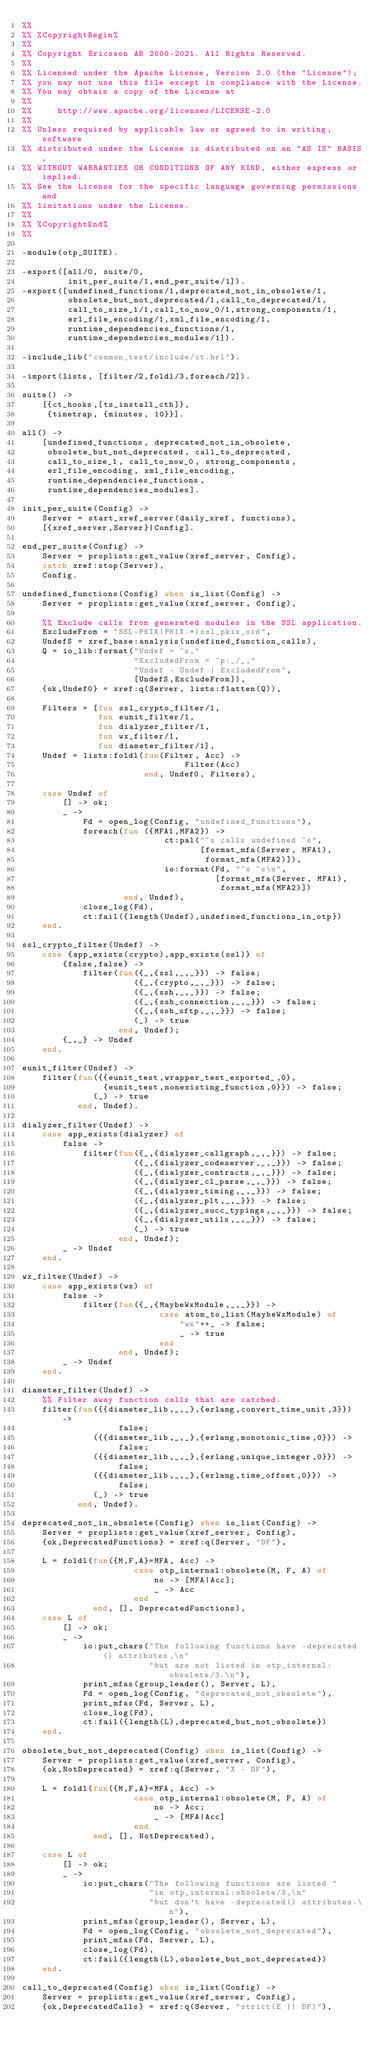Convert code to text. <code><loc_0><loc_0><loc_500><loc_500><_Erlang_>%%
%% %CopyrightBegin%
%%
%% Copyright Ericsson AB 2000-2021. All Rights Reserved.
%%
%% Licensed under the Apache License, Version 2.0 (the "License");
%% you may not use this file except in compliance with the License.
%% You may obtain a copy of the License at
%%
%%     http://www.apache.org/licenses/LICENSE-2.0
%%
%% Unless required by applicable law or agreed to in writing, software
%% distributed under the License is distributed on an "AS IS" BASIS,
%% WITHOUT WARRANTIES OR CONDITIONS OF ANY KIND, either express or implied.
%% See the License for the specific language governing permissions and
%% limitations under the License.
%%
%% %CopyrightEnd%
%%

-module(otp_SUITE).

-export([all/0, suite/0,
         init_per_suite/1,end_per_suite/1]).
-export([undefined_functions/1,deprecated_not_in_obsolete/1,
         obsolete_but_not_deprecated/1,call_to_deprecated/1,
         call_to_size_1/1,call_to_now_0/1,strong_components/1,
         erl_file_encoding/1,xml_file_encoding/1,
         runtime_dependencies_functions/1,
         runtime_dependencies_modules/1]).

-include_lib("common_test/include/ct.hrl").

-import(lists, [filter/2,foldl/3,foreach/2]).

suite() ->
    [{ct_hooks,[ts_install_cth]},
     {timetrap, {minutes, 10}}].

all() -> 
    [undefined_functions, deprecated_not_in_obsolete,
     obsolete_but_not_deprecated, call_to_deprecated,
     call_to_size_1, call_to_now_0, strong_components,
     erl_file_encoding, xml_file_encoding,
     runtime_dependencies_functions,
     runtime_dependencies_modules].

init_per_suite(Config) ->
    Server = start_xref_server(daily_xref, functions),
    [{xref_server,Server}|Config].

end_per_suite(Config) ->
    Server = proplists:get_value(xref_server, Config),
    catch xref:stop(Server),
    Config.

undefined_functions(Config) when is_list(Config) ->
    Server = proplists:get_value(xref_server, Config),

    %% Exclude calls from generated modules in the SSL application.
    ExcludeFrom = "SSL-PKIX|PKIX.*|ssl_pkix_oid",
    UndefS = xref_base:analysis(undefined_function_calls),
    Q = io_lib:format("Undef = ~s,"
                      "ExcludedFrom = ~p:_/_,"
                      "Undef - Undef | ExcludedFrom",
                      [UndefS,ExcludeFrom]),
    {ok,Undef0} = xref:q(Server, lists:flatten(Q)),

    Filters = [fun ssl_crypto_filter/1,
               fun eunit_filter/1,
               fun dialyzer_filter/1,
               fun wx_filter/1,
               fun diameter_filter/1],
    Undef = lists:foldl(fun(Filter, Acc) ->
                                Filter(Acc)
                        end, Undef0, Filters),

    case Undef of
        [] -> ok;
        _ ->
            Fd = open_log(Config, "undefined_functions"),
            foreach(fun ({MFA1,MFA2}) ->
                            ct:pal("~s calls undefined ~s",
                                   [format_mfa(Server, MFA1),
                                    format_mfa(MFA2)]),
                            io:format(Fd, "~s ~s\n",
                                      [format_mfa(Server, MFA1),
                                       format_mfa(MFA2)])
                    end, Undef),
            close_log(Fd),
            ct:fail({length(Undef),undefined_functions_in_otp})
    end.

ssl_crypto_filter(Undef) ->
    case {app_exists(crypto),app_exists(ssl)} of
        {false,false} ->
            filter(fun({_,{ssl,_,_}}) -> false;
                      ({_,{crypto,_,_}}) -> false;
                      ({_,{ssh,_,_}}) -> false;
                      ({_,{ssh_connection,_,_}}) -> false;
                      ({_,{ssh_sftp,_,_}}) -> false;
                      (_) -> true
                   end, Undef);
        {_,_} -> Undef
    end.

eunit_filter(Undef) ->
    filter(fun({{eunit_test,wrapper_test_exported_,0},
                {eunit_test,nonexisting_function,0}}) -> false;
              (_) -> true
           end, Undef).

dialyzer_filter(Undef) ->
    case app_exists(dialyzer) of
        false ->
            filter(fun({_,{dialyzer_callgraph,_,_}}) -> false;
                      ({_,{dialyzer_codeserver,_,_}}) -> false;
                      ({_,{dialyzer_contracts,_,_}}) -> false;
                      ({_,{dialyzer_cl_parse,_,_}}) -> false;
                      ({_,{dialyzer_timing,_,_}}) -> false;
                      ({_,{dialyzer_plt,_,_}}) -> false;
                      ({_,{dialyzer_succ_typings,_,_}}) -> false;
                      ({_,{dialyzer_utils,_,_}}) -> false;
                      (_) -> true
                   end, Undef);
        _ -> Undef
    end.

wx_filter(Undef) ->
    case app_exists(wx) of
        false ->
            filter(fun({_,{MaybeWxModule,_,_}}) ->
                           case atom_to_list(MaybeWxModule) of
                               "wx"++_ -> false;
                               _ -> true
                           end
                   end, Undef);
        _ -> Undef
    end.

diameter_filter(Undef) ->
    %% Filter away function calls that are catched.
    filter(fun({{diameter_lib,_,_},{erlang,convert_time_unit,3}}) ->
                   false;
              ({{diameter_lib,_,_},{erlang,monotonic_time,0}}) ->
                   false;
              ({{diameter_lib,_,_},{erlang,unique_integer,0}}) ->
                   false;
              ({{diameter_lib,_,_},{erlang,time_offset,0}}) ->
                   false;
              (_) -> true
           end, Undef).

deprecated_not_in_obsolete(Config) when is_list(Config) ->
    Server = proplists:get_value(xref_server, Config),
    {ok,DeprecatedFunctions} = xref:q(Server, "DF"),

    L = foldl(fun({M,F,A}=MFA, Acc) ->
                      case otp_internal:obsolete(M, F, A) of
                          no -> [MFA|Acc];
                          _ -> Acc
                      end
              end, [], DeprecatedFunctions),
    case L of
        [] -> ok;
        _ ->
            io:put_chars("The following functions have -deprecated() attributes,\n"
                         "but are not listed in otp_internal:obsolete/3.\n"),
            print_mfas(group_leader(), Server, L),
            Fd = open_log(Config, "deprecated_not_obsolete"),
            print_mfas(Fd, Server, L),
            close_log(Fd),
            ct:fail({length(L),deprecated_but_not_obsolete})
    end.

obsolete_but_not_deprecated(Config) when is_list(Config) ->
    Server = proplists:get_value(xref_server, Config),
    {ok,NotDeprecated} = xref:q(Server, "X - DF"),

    L = foldl(fun({M,F,A}=MFA, Acc) ->
                      case otp_internal:obsolete(M, F, A) of
                          no -> Acc;
                          _ -> [MFA|Acc]
                      end
              end, [], NotDeprecated),

    case L of
        [] -> ok;
        _ ->
            io:put_chars("The following functions are listed "
                         "in otp_internal:obsolete/3,\n"
                         "but don't have -deprecated() attributes.\n"),
            print_mfas(group_leader(), Server, L),
            Fd = open_log(Config, "obsolete_not_deprecated"),
            print_mfas(Fd, Server, L),
            close_log(Fd),
            ct:fail({length(L),obsolete_but_not_deprecated})
    end.

call_to_deprecated(Config) when is_list(Config) ->
    Server = proplists:get_value(xref_server, Config),
    {ok,DeprecatedCalls} = xref:q(Server, "strict(E || DF)"),</code> 